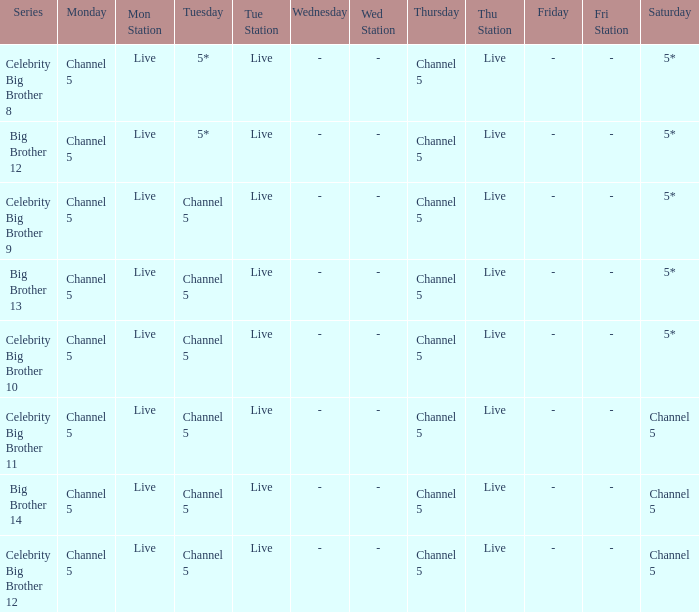Which series airs Saturday on Channel 5? Celebrity Big Brother 11, Big Brother 14, Celebrity Big Brother 12. 